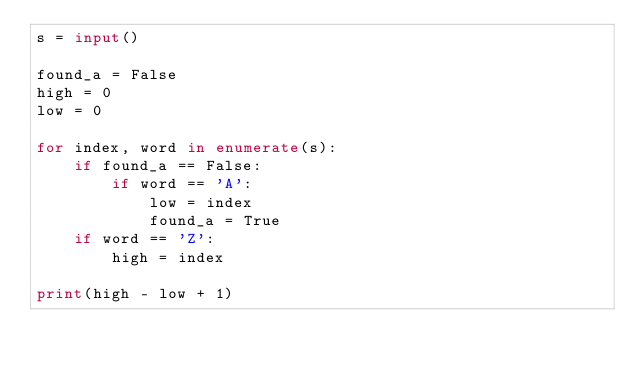<code> <loc_0><loc_0><loc_500><loc_500><_Python_>s = input()

found_a = False
high = 0
low = 0

for index, word in enumerate(s):
    if found_a == False:
        if word == 'A':
            low = index
            found_a = True
    if word == 'Z':
        high = index

print(high - low + 1)</code> 